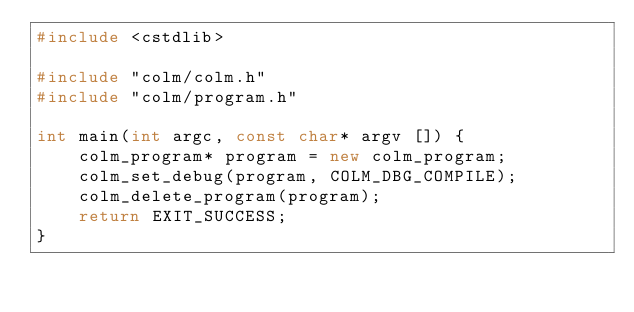Convert code to text. <code><loc_0><loc_0><loc_500><loc_500><_C++_>#include <cstdlib>

#include "colm/colm.h"
#include "colm/program.h"

int main(int argc, const char* argv []) {
    colm_program* program = new colm_program;
    colm_set_debug(program, COLM_DBG_COMPILE);
    colm_delete_program(program);
    return EXIT_SUCCESS;
}
</code> 